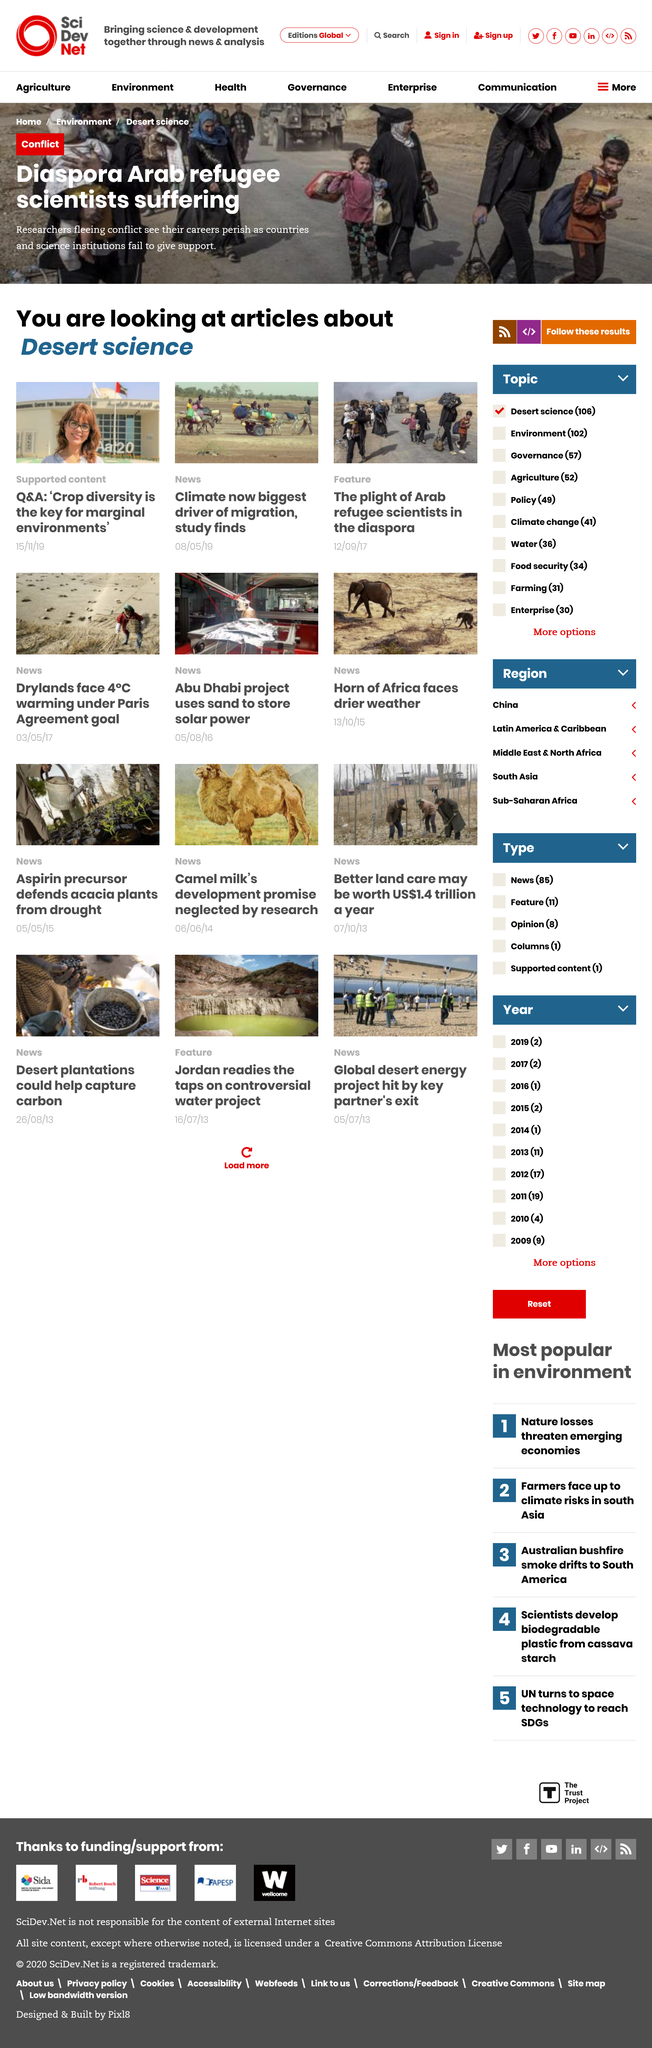Specify some key components in this picture. According to a study, climate change is the bigger driver of migration. In the headline, the suffering of diaspora Arab refugee scientists is being described. In marginal environments, crop diversity is key for ensuring successful agriculture. 